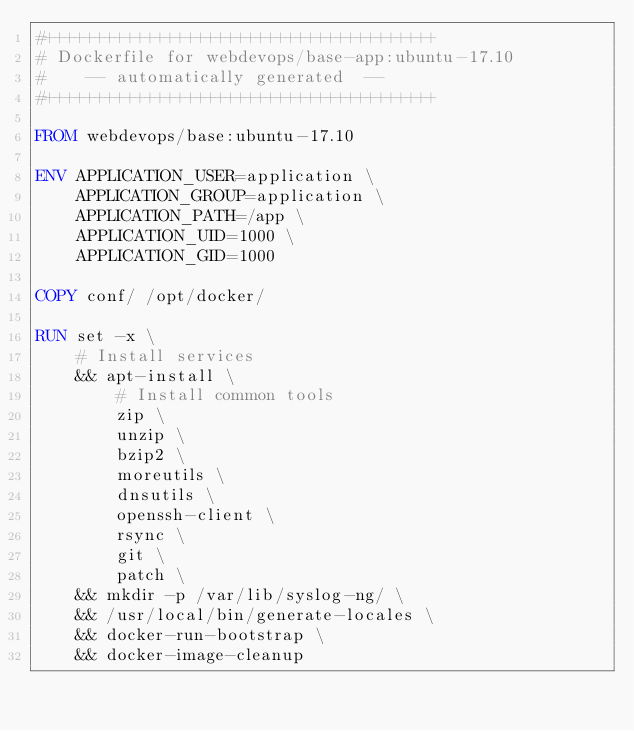<code> <loc_0><loc_0><loc_500><loc_500><_Dockerfile_>#+++++++++++++++++++++++++++++++++++++++
# Dockerfile for webdevops/base-app:ubuntu-17.10
#    -- automatically generated  --
#+++++++++++++++++++++++++++++++++++++++

FROM webdevops/base:ubuntu-17.10

ENV APPLICATION_USER=application \
    APPLICATION_GROUP=application \
    APPLICATION_PATH=/app \
    APPLICATION_UID=1000 \
    APPLICATION_GID=1000

COPY conf/ /opt/docker/

RUN set -x \
    # Install services
    && apt-install \
        # Install common tools
        zip \
        unzip \
        bzip2 \
        moreutils \
        dnsutils \
        openssh-client \
        rsync \
        git \
        patch \
    && mkdir -p /var/lib/syslog-ng/ \
    && /usr/local/bin/generate-locales \
    && docker-run-bootstrap \
    && docker-image-cleanup
</code> 